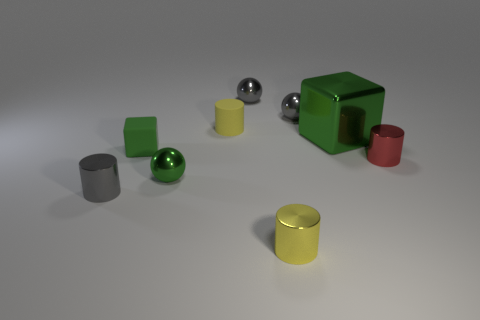Subtract all balls. How many objects are left? 6 Add 9 large shiny things. How many large shiny things are left? 10 Add 1 blocks. How many blocks exist? 3 Subtract 0 yellow cubes. How many objects are left? 9 Subtract all gray metallic cylinders. Subtract all small red metal cylinders. How many objects are left? 7 